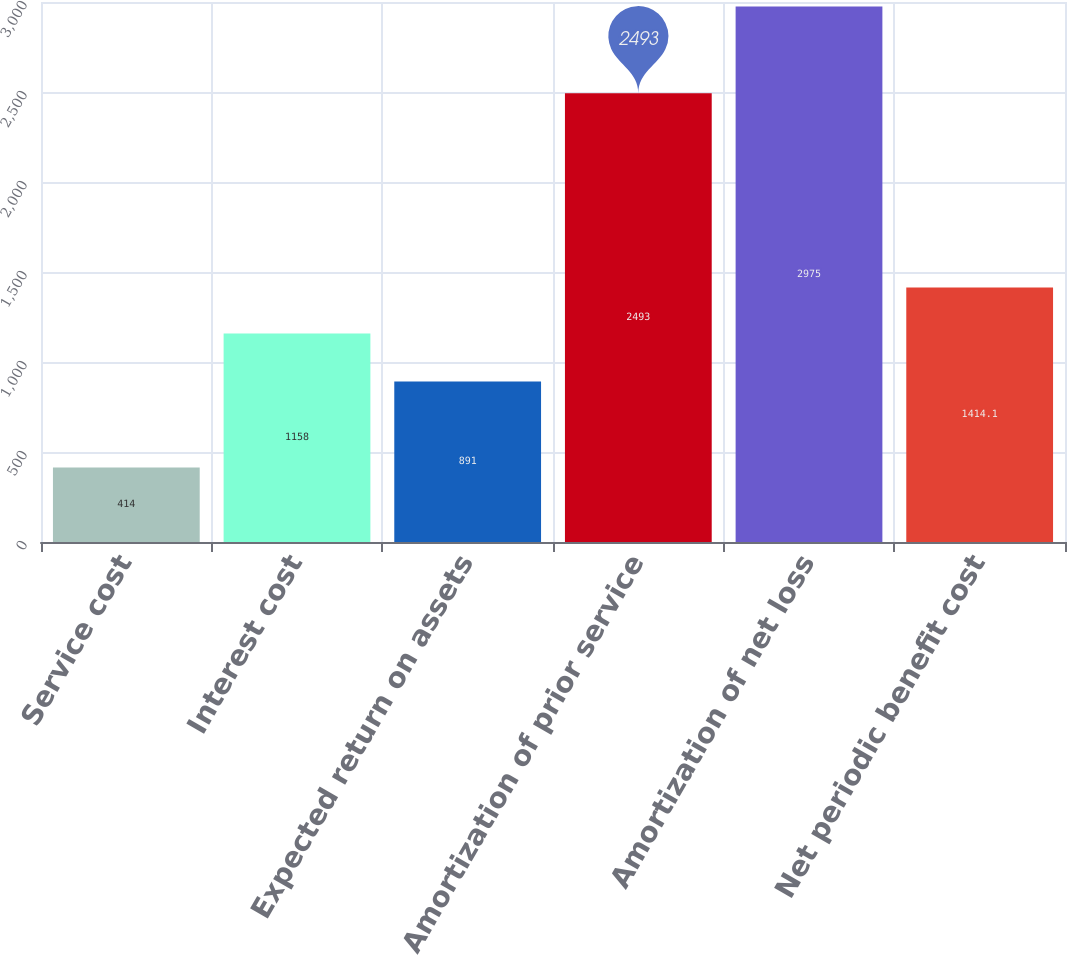Convert chart to OTSL. <chart><loc_0><loc_0><loc_500><loc_500><bar_chart><fcel>Service cost<fcel>Interest cost<fcel>Expected return on assets<fcel>Amortization of prior service<fcel>Amortization of net loss<fcel>Net periodic benefit cost<nl><fcel>414<fcel>1158<fcel>891<fcel>2493<fcel>2975<fcel>1414.1<nl></chart> 